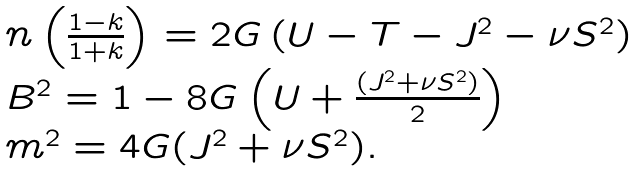Convert formula to latex. <formula><loc_0><loc_0><loc_500><loc_500>\begin{array} { l l } n \left ( \frac { 1 - k } { 1 + k } \right ) = 2 G \left ( U - T - J ^ { 2 } - \nu S ^ { 2 } \right ) \\ B ^ { 2 } = 1 - 8 G \left ( U + \frac { ( J ^ { 2 } + \nu S ^ { 2 } ) } { 2 } \right ) \\ m ^ { 2 } = 4 G ( J ^ { 2 } + \nu S ^ { 2 } ) . \end{array}</formula> 